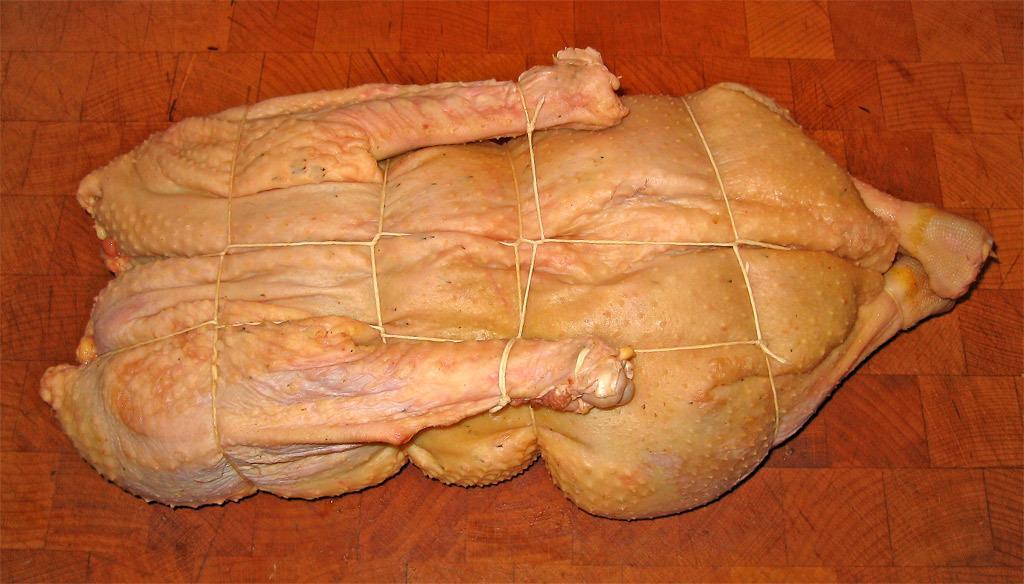In one or two sentences, can you explain what this image depicts? In this image there is meat tied with the threads , which is on the floor. 